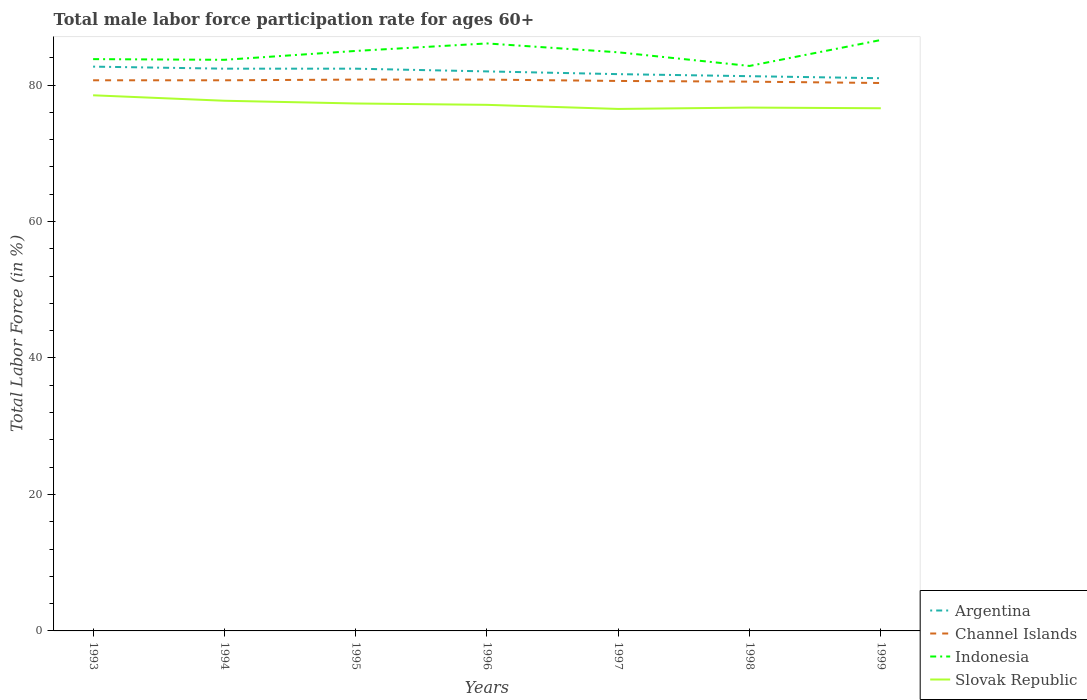How many different coloured lines are there?
Provide a short and direct response. 4. Is the number of lines equal to the number of legend labels?
Offer a very short reply. Yes. Across all years, what is the maximum male labor force participation rate in Slovak Republic?
Your response must be concise. 76.5. In which year was the male labor force participation rate in Argentina maximum?
Your answer should be very brief. 1999. What is the total male labor force participation rate in Argentina in the graph?
Your answer should be compact. 0.7. Is the male labor force participation rate in Slovak Republic strictly greater than the male labor force participation rate in Channel Islands over the years?
Your answer should be compact. Yes. How many years are there in the graph?
Your answer should be compact. 7. Does the graph contain any zero values?
Provide a short and direct response. No. Does the graph contain grids?
Your answer should be very brief. No. How are the legend labels stacked?
Provide a short and direct response. Vertical. What is the title of the graph?
Provide a succinct answer. Total male labor force participation rate for ages 60+. Does "Maldives" appear as one of the legend labels in the graph?
Your response must be concise. No. What is the Total Labor Force (in %) of Argentina in 1993?
Offer a terse response. 82.7. What is the Total Labor Force (in %) of Channel Islands in 1993?
Offer a terse response. 80.7. What is the Total Labor Force (in %) in Indonesia in 1993?
Your answer should be compact. 83.8. What is the Total Labor Force (in %) of Slovak Republic in 1993?
Make the answer very short. 78.5. What is the Total Labor Force (in %) in Argentina in 1994?
Ensure brevity in your answer.  82.4. What is the Total Labor Force (in %) in Channel Islands in 1994?
Your answer should be compact. 80.7. What is the Total Labor Force (in %) in Indonesia in 1994?
Your answer should be very brief. 83.7. What is the Total Labor Force (in %) in Slovak Republic in 1994?
Ensure brevity in your answer.  77.7. What is the Total Labor Force (in %) in Argentina in 1995?
Keep it short and to the point. 82.4. What is the Total Labor Force (in %) of Channel Islands in 1995?
Give a very brief answer. 80.8. What is the Total Labor Force (in %) of Indonesia in 1995?
Provide a succinct answer. 85. What is the Total Labor Force (in %) in Slovak Republic in 1995?
Your answer should be compact. 77.3. What is the Total Labor Force (in %) in Channel Islands in 1996?
Your answer should be compact. 80.8. What is the Total Labor Force (in %) in Indonesia in 1996?
Ensure brevity in your answer.  86.1. What is the Total Labor Force (in %) of Slovak Republic in 1996?
Your response must be concise. 77.1. What is the Total Labor Force (in %) of Argentina in 1997?
Keep it short and to the point. 81.6. What is the Total Labor Force (in %) in Channel Islands in 1997?
Offer a terse response. 80.6. What is the Total Labor Force (in %) in Indonesia in 1997?
Offer a very short reply. 84.8. What is the Total Labor Force (in %) in Slovak Republic in 1997?
Keep it short and to the point. 76.5. What is the Total Labor Force (in %) of Argentina in 1998?
Offer a terse response. 81.3. What is the Total Labor Force (in %) in Channel Islands in 1998?
Offer a terse response. 80.5. What is the Total Labor Force (in %) of Indonesia in 1998?
Your answer should be very brief. 82.8. What is the Total Labor Force (in %) of Slovak Republic in 1998?
Offer a very short reply. 76.7. What is the Total Labor Force (in %) in Channel Islands in 1999?
Give a very brief answer. 80.3. What is the Total Labor Force (in %) of Indonesia in 1999?
Make the answer very short. 86.6. What is the Total Labor Force (in %) in Slovak Republic in 1999?
Keep it short and to the point. 76.6. Across all years, what is the maximum Total Labor Force (in %) in Argentina?
Provide a succinct answer. 82.7. Across all years, what is the maximum Total Labor Force (in %) in Channel Islands?
Give a very brief answer. 80.8. Across all years, what is the maximum Total Labor Force (in %) in Indonesia?
Your answer should be very brief. 86.6. Across all years, what is the maximum Total Labor Force (in %) in Slovak Republic?
Ensure brevity in your answer.  78.5. Across all years, what is the minimum Total Labor Force (in %) of Channel Islands?
Offer a terse response. 80.3. Across all years, what is the minimum Total Labor Force (in %) in Indonesia?
Offer a very short reply. 82.8. Across all years, what is the minimum Total Labor Force (in %) of Slovak Republic?
Offer a very short reply. 76.5. What is the total Total Labor Force (in %) in Argentina in the graph?
Give a very brief answer. 573.4. What is the total Total Labor Force (in %) of Channel Islands in the graph?
Give a very brief answer. 564.4. What is the total Total Labor Force (in %) in Indonesia in the graph?
Make the answer very short. 592.8. What is the total Total Labor Force (in %) in Slovak Republic in the graph?
Offer a very short reply. 540.4. What is the difference between the Total Labor Force (in %) of Indonesia in 1993 and that in 1994?
Your answer should be compact. 0.1. What is the difference between the Total Labor Force (in %) of Indonesia in 1993 and that in 1995?
Give a very brief answer. -1.2. What is the difference between the Total Labor Force (in %) of Slovak Republic in 1993 and that in 1995?
Make the answer very short. 1.2. What is the difference between the Total Labor Force (in %) of Argentina in 1993 and that in 1996?
Make the answer very short. 0.7. What is the difference between the Total Labor Force (in %) of Indonesia in 1993 and that in 1996?
Provide a short and direct response. -2.3. What is the difference between the Total Labor Force (in %) of Slovak Republic in 1993 and that in 1996?
Ensure brevity in your answer.  1.4. What is the difference between the Total Labor Force (in %) in Argentina in 1993 and that in 1997?
Your response must be concise. 1.1. What is the difference between the Total Labor Force (in %) of Slovak Republic in 1993 and that in 1997?
Ensure brevity in your answer.  2. What is the difference between the Total Labor Force (in %) in Argentina in 1993 and that in 1998?
Provide a succinct answer. 1.4. What is the difference between the Total Labor Force (in %) in Slovak Republic in 1993 and that in 1998?
Offer a terse response. 1.8. What is the difference between the Total Labor Force (in %) in Channel Islands in 1993 and that in 1999?
Provide a short and direct response. 0.4. What is the difference between the Total Labor Force (in %) of Slovak Republic in 1993 and that in 1999?
Provide a succinct answer. 1.9. What is the difference between the Total Labor Force (in %) in Slovak Republic in 1994 and that in 1995?
Your answer should be compact. 0.4. What is the difference between the Total Labor Force (in %) in Argentina in 1994 and that in 1996?
Offer a terse response. 0.4. What is the difference between the Total Labor Force (in %) of Channel Islands in 1994 and that in 1996?
Give a very brief answer. -0.1. What is the difference between the Total Labor Force (in %) in Slovak Republic in 1994 and that in 1996?
Offer a very short reply. 0.6. What is the difference between the Total Labor Force (in %) in Argentina in 1994 and that in 1997?
Provide a succinct answer. 0.8. What is the difference between the Total Labor Force (in %) of Slovak Republic in 1994 and that in 1998?
Offer a very short reply. 1. What is the difference between the Total Labor Force (in %) in Argentina in 1995 and that in 1996?
Offer a very short reply. 0.4. What is the difference between the Total Labor Force (in %) of Channel Islands in 1995 and that in 1997?
Your answer should be very brief. 0.2. What is the difference between the Total Labor Force (in %) of Slovak Republic in 1995 and that in 1997?
Your answer should be compact. 0.8. What is the difference between the Total Labor Force (in %) in Argentina in 1995 and that in 1998?
Provide a succinct answer. 1.1. What is the difference between the Total Labor Force (in %) in Indonesia in 1995 and that in 1998?
Give a very brief answer. 2.2. What is the difference between the Total Labor Force (in %) in Argentina in 1995 and that in 1999?
Offer a terse response. 1.4. What is the difference between the Total Labor Force (in %) in Channel Islands in 1995 and that in 1999?
Offer a very short reply. 0.5. What is the difference between the Total Labor Force (in %) of Indonesia in 1995 and that in 1999?
Your answer should be compact. -1.6. What is the difference between the Total Labor Force (in %) of Channel Islands in 1996 and that in 1997?
Offer a very short reply. 0.2. What is the difference between the Total Labor Force (in %) in Indonesia in 1996 and that in 1997?
Offer a very short reply. 1.3. What is the difference between the Total Labor Force (in %) in Slovak Republic in 1996 and that in 1997?
Your response must be concise. 0.6. What is the difference between the Total Labor Force (in %) in Argentina in 1996 and that in 1999?
Give a very brief answer. 1. What is the difference between the Total Labor Force (in %) of Channel Islands in 1996 and that in 1999?
Your response must be concise. 0.5. What is the difference between the Total Labor Force (in %) in Indonesia in 1996 and that in 1999?
Give a very brief answer. -0.5. What is the difference between the Total Labor Force (in %) of Argentina in 1997 and that in 1998?
Provide a succinct answer. 0.3. What is the difference between the Total Labor Force (in %) of Channel Islands in 1997 and that in 1998?
Ensure brevity in your answer.  0.1. What is the difference between the Total Labor Force (in %) of Indonesia in 1997 and that in 1998?
Your answer should be very brief. 2. What is the difference between the Total Labor Force (in %) in Argentina in 1997 and that in 1999?
Your response must be concise. 0.6. What is the difference between the Total Labor Force (in %) of Channel Islands in 1997 and that in 1999?
Ensure brevity in your answer.  0.3. What is the difference between the Total Labor Force (in %) of Argentina in 1998 and that in 1999?
Your answer should be compact. 0.3. What is the difference between the Total Labor Force (in %) in Channel Islands in 1998 and that in 1999?
Provide a short and direct response. 0.2. What is the difference between the Total Labor Force (in %) of Indonesia in 1998 and that in 1999?
Make the answer very short. -3.8. What is the difference between the Total Labor Force (in %) of Slovak Republic in 1998 and that in 1999?
Your answer should be compact. 0.1. What is the difference between the Total Labor Force (in %) in Argentina in 1993 and the Total Labor Force (in %) in Indonesia in 1994?
Give a very brief answer. -1. What is the difference between the Total Labor Force (in %) in Indonesia in 1993 and the Total Labor Force (in %) in Slovak Republic in 1994?
Keep it short and to the point. 6.1. What is the difference between the Total Labor Force (in %) in Argentina in 1993 and the Total Labor Force (in %) in Indonesia in 1995?
Ensure brevity in your answer.  -2.3. What is the difference between the Total Labor Force (in %) of Channel Islands in 1993 and the Total Labor Force (in %) of Slovak Republic in 1995?
Offer a terse response. 3.4. What is the difference between the Total Labor Force (in %) of Indonesia in 1993 and the Total Labor Force (in %) of Slovak Republic in 1995?
Give a very brief answer. 6.5. What is the difference between the Total Labor Force (in %) of Argentina in 1993 and the Total Labor Force (in %) of Indonesia in 1996?
Keep it short and to the point. -3.4. What is the difference between the Total Labor Force (in %) of Indonesia in 1993 and the Total Labor Force (in %) of Slovak Republic in 1996?
Provide a short and direct response. 6.7. What is the difference between the Total Labor Force (in %) of Channel Islands in 1993 and the Total Labor Force (in %) of Indonesia in 1997?
Offer a terse response. -4.1. What is the difference between the Total Labor Force (in %) of Argentina in 1993 and the Total Labor Force (in %) of Channel Islands in 1998?
Your answer should be very brief. 2.2. What is the difference between the Total Labor Force (in %) of Argentina in 1993 and the Total Labor Force (in %) of Indonesia in 1998?
Your response must be concise. -0.1. What is the difference between the Total Labor Force (in %) in Channel Islands in 1993 and the Total Labor Force (in %) in Indonesia in 1999?
Provide a succinct answer. -5.9. What is the difference between the Total Labor Force (in %) in Indonesia in 1993 and the Total Labor Force (in %) in Slovak Republic in 1999?
Offer a terse response. 7.2. What is the difference between the Total Labor Force (in %) in Argentina in 1994 and the Total Labor Force (in %) in Indonesia in 1995?
Your answer should be very brief. -2.6. What is the difference between the Total Labor Force (in %) in Channel Islands in 1994 and the Total Labor Force (in %) in Indonesia in 1995?
Provide a succinct answer. -4.3. What is the difference between the Total Labor Force (in %) in Argentina in 1994 and the Total Labor Force (in %) in Indonesia in 1996?
Make the answer very short. -3.7. What is the difference between the Total Labor Force (in %) in Indonesia in 1994 and the Total Labor Force (in %) in Slovak Republic in 1996?
Offer a very short reply. 6.6. What is the difference between the Total Labor Force (in %) of Argentina in 1994 and the Total Labor Force (in %) of Channel Islands in 1997?
Provide a short and direct response. 1.8. What is the difference between the Total Labor Force (in %) in Argentina in 1994 and the Total Labor Force (in %) in Indonesia in 1997?
Your answer should be compact. -2.4. What is the difference between the Total Labor Force (in %) in Channel Islands in 1994 and the Total Labor Force (in %) in Indonesia in 1997?
Provide a succinct answer. -4.1. What is the difference between the Total Labor Force (in %) of Argentina in 1994 and the Total Labor Force (in %) of Indonesia in 1998?
Your answer should be compact. -0.4. What is the difference between the Total Labor Force (in %) of Argentina in 1994 and the Total Labor Force (in %) of Slovak Republic in 1998?
Provide a short and direct response. 5.7. What is the difference between the Total Labor Force (in %) in Channel Islands in 1994 and the Total Labor Force (in %) in Slovak Republic in 1998?
Your response must be concise. 4. What is the difference between the Total Labor Force (in %) in Indonesia in 1994 and the Total Labor Force (in %) in Slovak Republic in 1998?
Keep it short and to the point. 7. What is the difference between the Total Labor Force (in %) in Argentina in 1994 and the Total Labor Force (in %) in Channel Islands in 1999?
Provide a succinct answer. 2.1. What is the difference between the Total Labor Force (in %) of Argentina in 1994 and the Total Labor Force (in %) of Indonesia in 1999?
Keep it short and to the point. -4.2. What is the difference between the Total Labor Force (in %) in Argentina in 1994 and the Total Labor Force (in %) in Slovak Republic in 1999?
Keep it short and to the point. 5.8. What is the difference between the Total Labor Force (in %) in Channel Islands in 1994 and the Total Labor Force (in %) in Indonesia in 1999?
Your answer should be very brief. -5.9. What is the difference between the Total Labor Force (in %) of Channel Islands in 1995 and the Total Labor Force (in %) of Indonesia in 1996?
Offer a terse response. -5.3. What is the difference between the Total Labor Force (in %) in Channel Islands in 1995 and the Total Labor Force (in %) in Slovak Republic in 1996?
Your answer should be compact. 3.7. What is the difference between the Total Labor Force (in %) of Channel Islands in 1995 and the Total Labor Force (in %) of Indonesia in 1997?
Make the answer very short. -4. What is the difference between the Total Labor Force (in %) of Channel Islands in 1995 and the Total Labor Force (in %) of Slovak Republic in 1997?
Your answer should be compact. 4.3. What is the difference between the Total Labor Force (in %) in Argentina in 1995 and the Total Labor Force (in %) in Channel Islands in 1998?
Ensure brevity in your answer.  1.9. What is the difference between the Total Labor Force (in %) in Channel Islands in 1995 and the Total Labor Force (in %) in Indonesia in 1998?
Offer a terse response. -2. What is the difference between the Total Labor Force (in %) of Channel Islands in 1995 and the Total Labor Force (in %) of Slovak Republic in 1998?
Provide a succinct answer. 4.1. What is the difference between the Total Labor Force (in %) in Indonesia in 1995 and the Total Labor Force (in %) in Slovak Republic in 1998?
Your answer should be very brief. 8.3. What is the difference between the Total Labor Force (in %) of Argentina in 1995 and the Total Labor Force (in %) of Channel Islands in 1999?
Your answer should be compact. 2.1. What is the difference between the Total Labor Force (in %) in Argentina in 1995 and the Total Labor Force (in %) in Indonesia in 1999?
Your answer should be compact. -4.2. What is the difference between the Total Labor Force (in %) in Channel Islands in 1995 and the Total Labor Force (in %) in Slovak Republic in 1999?
Provide a succinct answer. 4.2. What is the difference between the Total Labor Force (in %) of Argentina in 1996 and the Total Labor Force (in %) of Indonesia in 1997?
Your answer should be very brief. -2.8. What is the difference between the Total Labor Force (in %) in Argentina in 1996 and the Total Labor Force (in %) in Slovak Republic in 1997?
Provide a short and direct response. 5.5. What is the difference between the Total Labor Force (in %) in Indonesia in 1996 and the Total Labor Force (in %) in Slovak Republic in 1997?
Offer a very short reply. 9.6. What is the difference between the Total Labor Force (in %) of Argentina in 1996 and the Total Labor Force (in %) of Slovak Republic in 1999?
Make the answer very short. 5.4. What is the difference between the Total Labor Force (in %) in Channel Islands in 1996 and the Total Labor Force (in %) in Slovak Republic in 1999?
Give a very brief answer. 4.2. What is the difference between the Total Labor Force (in %) in Indonesia in 1996 and the Total Labor Force (in %) in Slovak Republic in 1999?
Provide a short and direct response. 9.5. What is the difference between the Total Labor Force (in %) of Argentina in 1997 and the Total Labor Force (in %) of Channel Islands in 1998?
Ensure brevity in your answer.  1.1. What is the difference between the Total Labor Force (in %) of Argentina in 1997 and the Total Labor Force (in %) of Slovak Republic in 1998?
Ensure brevity in your answer.  4.9. What is the difference between the Total Labor Force (in %) in Channel Islands in 1997 and the Total Labor Force (in %) in Slovak Republic in 1998?
Your answer should be very brief. 3.9. What is the difference between the Total Labor Force (in %) in Indonesia in 1997 and the Total Labor Force (in %) in Slovak Republic in 1998?
Your answer should be very brief. 8.1. What is the difference between the Total Labor Force (in %) in Argentina in 1997 and the Total Labor Force (in %) in Channel Islands in 1999?
Ensure brevity in your answer.  1.3. What is the difference between the Total Labor Force (in %) in Argentina in 1997 and the Total Labor Force (in %) in Indonesia in 1999?
Give a very brief answer. -5. What is the difference between the Total Labor Force (in %) in Argentina in 1997 and the Total Labor Force (in %) in Slovak Republic in 1999?
Your answer should be compact. 5. What is the difference between the Total Labor Force (in %) of Channel Islands in 1997 and the Total Labor Force (in %) of Indonesia in 1999?
Offer a very short reply. -6. What is the difference between the Total Labor Force (in %) of Channel Islands in 1997 and the Total Labor Force (in %) of Slovak Republic in 1999?
Your answer should be very brief. 4. What is the difference between the Total Labor Force (in %) in Argentina in 1998 and the Total Labor Force (in %) in Channel Islands in 1999?
Ensure brevity in your answer.  1. What is the difference between the Total Labor Force (in %) in Indonesia in 1998 and the Total Labor Force (in %) in Slovak Republic in 1999?
Make the answer very short. 6.2. What is the average Total Labor Force (in %) of Argentina per year?
Your response must be concise. 81.91. What is the average Total Labor Force (in %) in Channel Islands per year?
Ensure brevity in your answer.  80.63. What is the average Total Labor Force (in %) in Indonesia per year?
Offer a very short reply. 84.69. What is the average Total Labor Force (in %) of Slovak Republic per year?
Provide a short and direct response. 77.2. In the year 1993, what is the difference between the Total Labor Force (in %) in Argentina and Total Labor Force (in %) in Channel Islands?
Provide a succinct answer. 2. In the year 1993, what is the difference between the Total Labor Force (in %) in Argentina and Total Labor Force (in %) in Slovak Republic?
Offer a terse response. 4.2. In the year 1993, what is the difference between the Total Labor Force (in %) in Channel Islands and Total Labor Force (in %) in Indonesia?
Give a very brief answer. -3.1. In the year 1993, what is the difference between the Total Labor Force (in %) in Channel Islands and Total Labor Force (in %) in Slovak Republic?
Your answer should be compact. 2.2. In the year 1993, what is the difference between the Total Labor Force (in %) in Indonesia and Total Labor Force (in %) in Slovak Republic?
Ensure brevity in your answer.  5.3. In the year 1994, what is the difference between the Total Labor Force (in %) of Channel Islands and Total Labor Force (in %) of Indonesia?
Offer a very short reply. -3. In the year 1994, what is the difference between the Total Labor Force (in %) in Channel Islands and Total Labor Force (in %) in Slovak Republic?
Your answer should be compact. 3. In the year 1995, what is the difference between the Total Labor Force (in %) of Channel Islands and Total Labor Force (in %) of Indonesia?
Your answer should be compact. -4.2. In the year 1995, what is the difference between the Total Labor Force (in %) of Channel Islands and Total Labor Force (in %) of Slovak Republic?
Your response must be concise. 3.5. In the year 1995, what is the difference between the Total Labor Force (in %) of Indonesia and Total Labor Force (in %) of Slovak Republic?
Ensure brevity in your answer.  7.7. In the year 1997, what is the difference between the Total Labor Force (in %) in Argentina and Total Labor Force (in %) in Slovak Republic?
Your answer should be compact. 5.1. In the year 1997, what is the difference between the Total Labor Force (in %) in Channel Islands and Total Labor Force (in %) in Indonesia?
Make the answer very short. -4.2. In the year 1997, what is the difference between the Total Labor Force (in %) in Channel Islands and Total Labor Force (in %) in Slovak Republic?
Your answer should be very brief. 4.1. In the year 1998, what is the difference between the Total Labor Force (in %) in Argentina and Total Labor Force (in %) in Channel Islands?
Keep it short and to the point. 0.8. In the year 1998, what is the difference between the Total Labor Force (in %) of Argentina and Total Labor Force (in %) of Indonesia?
Offer a terse response. -1.5. In the year 1998, what is the difference between the Total Labor Force (in %) in Channel Islands and Total Labor Force (in %) in Indonesia?
Provide a succinct answer. -2.3. In the year 1998, what is the difference between the Total Labor Force (in %) of Channel Islands and Total Labor Force (in %) of Slovak Republic?
Your answer should be compact. 3.8. In the year 1998, what is the difference between the Total Labor Force (in %) in Indonesia and Total Labor Force (in %) in Slovak Republic?
Your answer should be compact. 6.1. In the year 1999, what is the difference between the Total Labor Force (in %) of Argentina and Total Labor Force (in %) of Indonesia?
Ensure brevity in your answer.  -5.6. In the year 1999, what is the difference between the Total Labor Force (in %) in Argentina and Total Labor Force (in %) in Slovak Republic?
Offer a very short reply. 4.4. In the year 1999, what is the difference between the Total Labor Force (in %) of Channel Islands and Total Labor Force (in %) of Indonesia?
Offer a terse response. -6.3. In the year 1999, what is the difference between the Total Labor Force (in %) of Channel Islands and Total Labor Force (in %) of Slovak Republic?
Keep it short and to the point. 3.7. In the year 1999, what is the difference between the Total Labor Force (in %) in Indonesia and Total Labor Force (in %) in Slovak Republic?
Ensure brevity in your answer.  10. What is the ratio of the Total Labor Force (in %) in Channel Islands in 1993 to that in 1994?
Provide a short and direct response. 1. What is the ratio of the Total Labor Force (in %) in Indonesia in 1993 to that in 1994?
Give a very brief answer. 1. What is the ratio of the Total Labor Force (in %) in Slovak Republic in 1993 to that in 1994?
Your answer should be very brief. 1.01. What is the ratio of the Total Labor Force (in %) in Indonesia in 1993 to that in 1995?
Offer a very short reply. 0.99. What is the ratio of the Total Labor Force (in %) in Slovak Republic in 1993 to that in 1995?
Offer a very short reply. 1.02. What is the ratio of the Total Labor Force (in %) in Argentina in 1993 to that in 1996?
Your response must be concise. 1.01. What is the ratio of the Total Labor Force (in %) of Channel Islands in 1993 to that in 1996?
Give a very brief answer. 1. What is the ratio of the Total Labor Force (in %) in Indonesia in 1993 to that in 1996?
Your response must be concise. 0.97. What is the ratio of the Total Labor Force (in %) of Slovak Republic in 1993 to that in 1996?
Give a very brief answer. 1.02. What is the ratio of the Total Labor Force (in %) in Argentina in 1993 to that in 1997?
Keep it short and to the point. 1.01. What is the ratio of the Total Labor Force (in %) in Channel Islands in 1993 to that in 1997?
Keep it short and to the point. 1. What is the ratio of the Total Labor Force (in %) of Indonesia in 1993 to that in 1997?
Give a very brief answer. 0.99. What is the ratio of the Total Labor Force (in %) of Slovak Republic in 1993 to that in 1997?
Ensure brevity in your answer.  1.03. What is the ratio of the Total Labor Force (in %) of Argentina in 1993 to that in 1998?
Offer a very short reply. 1.02. What is the ratio of the Total Labor Force (in %) in Indonesia in 1993 to that in 1998?
Give a very brief answer. 1.01. What is the ratio of the Total Labor Force (in %) in Slovak Republic in 1993 to that in 1998?
Make the answer very short. 1.02. What is the ratio of the Total Labor Force (in %) in Argentina in 1993 to that in 1999?
Offer a terse response. 1.02. What is the ratio of the Total Labor Force (in %) of Channel Islands in 1993 to that in 1999?
Ensure brevity in your answer.  1. What is the ratio of the Total Labor Force (in %) in Slovak Republic in 1993 to that in 1999?
Ensure brevity in your answer.  1.02. What is the ratio of the Total Labor Force (in %) in Argentina in 1994 to that in 1995?
Your answer should be very brief. 1. What is the ratio of the Total Labor Force (in %) of Indonesia in 1994 to that in 1995?
Your response must be concise. 0.98. What is the ratio of the Total Labor Force (in %) of Slovak Republic in 1994 to that in 1995?
Your answer should be compact. 1.01. What is the ratio of the Total Labor Force (in %) of Indonesia in 1994 to that in 1996?
Your response must be concise. 0.97. What is the ratio of the Total Labor Force (in %) in Argentina in 1994 to that in 1997?
Your answer should be compact. 1.01. What is the ratio of the Total Labor Force (in %) of Channel Islands in 1994 to that in 1997?
Your answer should be very brief. 1. What is the ratio of the Total Labor Force (in %) in Slovak Republic in 1994 to that in 1997?
Provide a succinct answer. 1.02. What is the ratio of the Total Labor Force (in %) of Argentina in 1994 to that in 1998?
Provide a short and direct response. 1.01. What is the ratio of the Total Labor Force (in %) in Channel Islands in 1994 to that in 1998?
Provide a short and direct response. 1. What is the ratio of the Total Labor Force (in %) in Indonesia in 1994 to that in 1998?
Keep it short and to the point. 1.01. What is the ratio of the Total Labor Force (in %) of Slovak Republic in 1994 to that in 1998?
Provide a short and direct response. 1.01. What is the ratio of the Total Labor Force (in %) in Argentina in 1994 to that in 1999?
Your response must be concise. 1.02. What is the ratio of the Total Labor Force (in %) in Channel Islands in 1994 to that in 1999?
Keep it short and to the point. 1. What is the ratio of the Total Labor Force (in %) of Indonesia in 1994 to that in 1999?
Provide a short and direct response. 0.97. What is the ratio of the Total Labor Force (in %) of Slovak Republic in 1994 to that in 1999?
Offer a terse response. 1.01. What is the ratio of the Total Labor Force (in %) in Argentina in 1995 to that in 1996?
Ensure brevity in your answer.  1. What is the ratio of the Total Labor Force (in %) in Channel Islands in 1995 to that in 1996?
Make the answer very short. 1. What is the ratio of the Total Labor Force (in %) in Indonesia in 1995 to that in 1996?
Ensure brevity in your answer.  0.99. What is the ratio of the Total Labor Force (in %) in Slovak Republic in 1995 to that in 1996?
Offer a terse response. 1. What is the ratio of the Total Labor Force (in %) of Argentina in 1995 to that in 1997?
Provide a short and direct response. 1.01. What is the ratio of the Total Labor Force (in %) of Channel Islands in 1995 to that in 1997?
Your response must be concise. 1. What is the ratio of the Total Labor Force (in %) in Slovak Republic in 1995 to that in 1997?
Ensure brevity in your answer.  1.01. What is the ratio of the Total Labor Force (in %) in Argentina in 1995 to that in 1998?
Your answer should be very brief. 1.01. What is the ratio of the Total Labor Force (in %) in Channel Islands in 1995 to that in 1998?
Provide a short and direct response. 1. What is the ratio of the Total Labor Force (in %) in Indonesia in 1995 to that in 1998?
Your answer should be very brief. 1.03. What is the ratio of the Total Labor Force (in %) of Slovak Republic in 1995 to that in 1998?
Provide a short and direct response. 1.01. What is the ratio of the Total Labor Force (in %) of Argentina in 1995 to that in 1999?
Make the answer very short. 1.02. What is the ratio of the Total Labor Force (in %) in Channel Islands in 1995 to that in 1999?
Your answer should be very brief. 1.01. What is the ratio of the Total Labor Force (in %) of Indonesia in 1995 to that in 1999?
Offer a terse response. 0.98. What is the ratio of the Total Labor Force (in %) of Slovak Republic in 1995 to that in 1999?
Your answer should be very brief. 1.01. What is the ratio of the Total Labor Force (in %) of Argentina in 1996 to that in 1997?
Your answer should be very brief. 1. What is the ratio of the Total Labor Force (in %) of Indonesia in 1996 to that in 1997?
Keep it short and to the point. 1.02. What is the ratio of the Total Labor Force (in %) in Argentina in 1996 to that in 1998?
Offer a terse response. 1.01. What is the ratio of the Total Labor Force (in %) of Indonesia in 1996 to that in 1998?
Provide a succinct answer. 1.04. What is the ratio of the Total Labor Force (in %) in Slovak Republic in 1996 to that in 1998?
Offer a terse response. 1.01. What is the ratio of the Total Labor Force (in %) in Argentina in 1996 to that in 1999?
Your answer should be compact. 1.01. What is the ratio of the Total Labor Force (in %) in Channel Islands in 1996 to that in 1999?
Your answer should be very brief. 1.01. What is the ratio of the Total Labor Force (in %) of Slovak Republic in 1996 to that in 1999?
Your response must be concise. 1.01. What is the ratio of the Total Labor Force (in %) in Channel Islands in 1997 to that in 1998?
Ensure brevity in your answer.  1. What is the ratio of the Total Labor Force (in %) in Indonesia in 1997 to that in 1998?
Provide a short and direct response. 1.02. What is the ratio of the Total Labor Force (in %) in Slovak Republic in 1997 to that in 1998?
Provide a succinct answer. 1. What is the ratio of the Total Labor Force (in %) in Argentina in 1997 to that in 1999?
Your answer should be compact. 1.01. What is the ratio of the Total Labor Force (in %) of Indonesia in 1997 to that in 1999?
Ensure brevity in your answer.  0.98. What is the ratio of the Total Labor Force (in %) of Indonesia in 1998 to that in 1999?
Offer a terse response. 0.96. What is the difference between the highest and the second highest Total Labor Force (in %) in Slovak Republic?
Ensure brevity in your answer.  0.8. What is the difference between the highest and the lowest Total Labor Force (in %) of Channel Islands?
Your response must be concise. 0.5. What is the difference between the highest and the lowest Total Labor Force (in %) of Indonesia?
Your answer should be very brief. 3.8. What is the difference between the highest and the lowest Total Labor Force (in %) in Slovak Republic?
Provide a succinct answer. 2. 